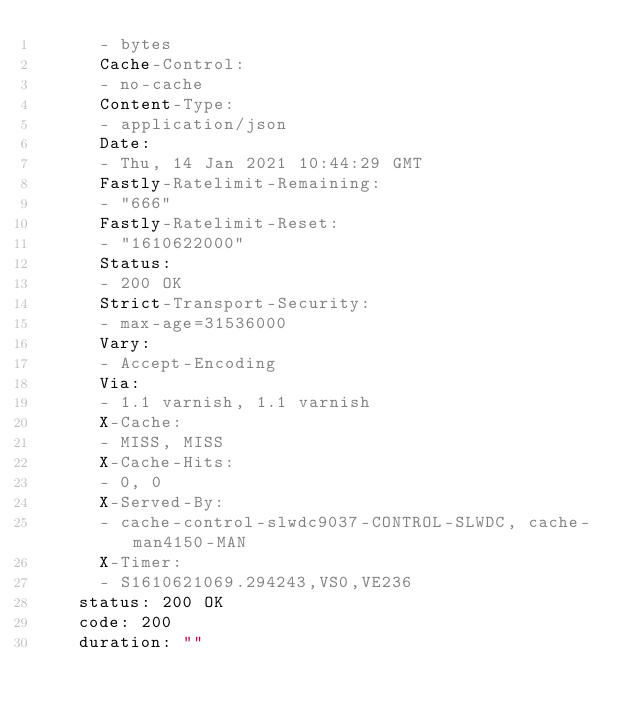<code> <loc_0><loc_0><loc_500><loc_500><_YAML_>      - bytes
      Cache-Control:
      - no-cache
      Content-Type:
      - application/json
      Date:
      - Thu, 14 Jan 2021 10:44:29 GMT
      Fastly-Ratelimit-Remaining:
      - "666"
      Fastly-Ratelimit-Reset:
      - "1610622000"
      Status:
      - 200 OK
      Strict-Transport-Security:
      - max-age=31536000
      Vary:
      - Accept-Encoding
      Via:
      - 1.1 varnish, 1.1 varnish
      X-Cache:
      - MISS, MISS
      X-Cache-Hits:
      - 0, 0
      X-Served-By:
      - cache-control-slwdc9037-CONTROL-SLWDC, cache-man4150-MAN
      X-Timer:
      - S1610621069.294243,VS0,VE236
    status: 200 OK
    code: 200
    duration: ""
</code> 